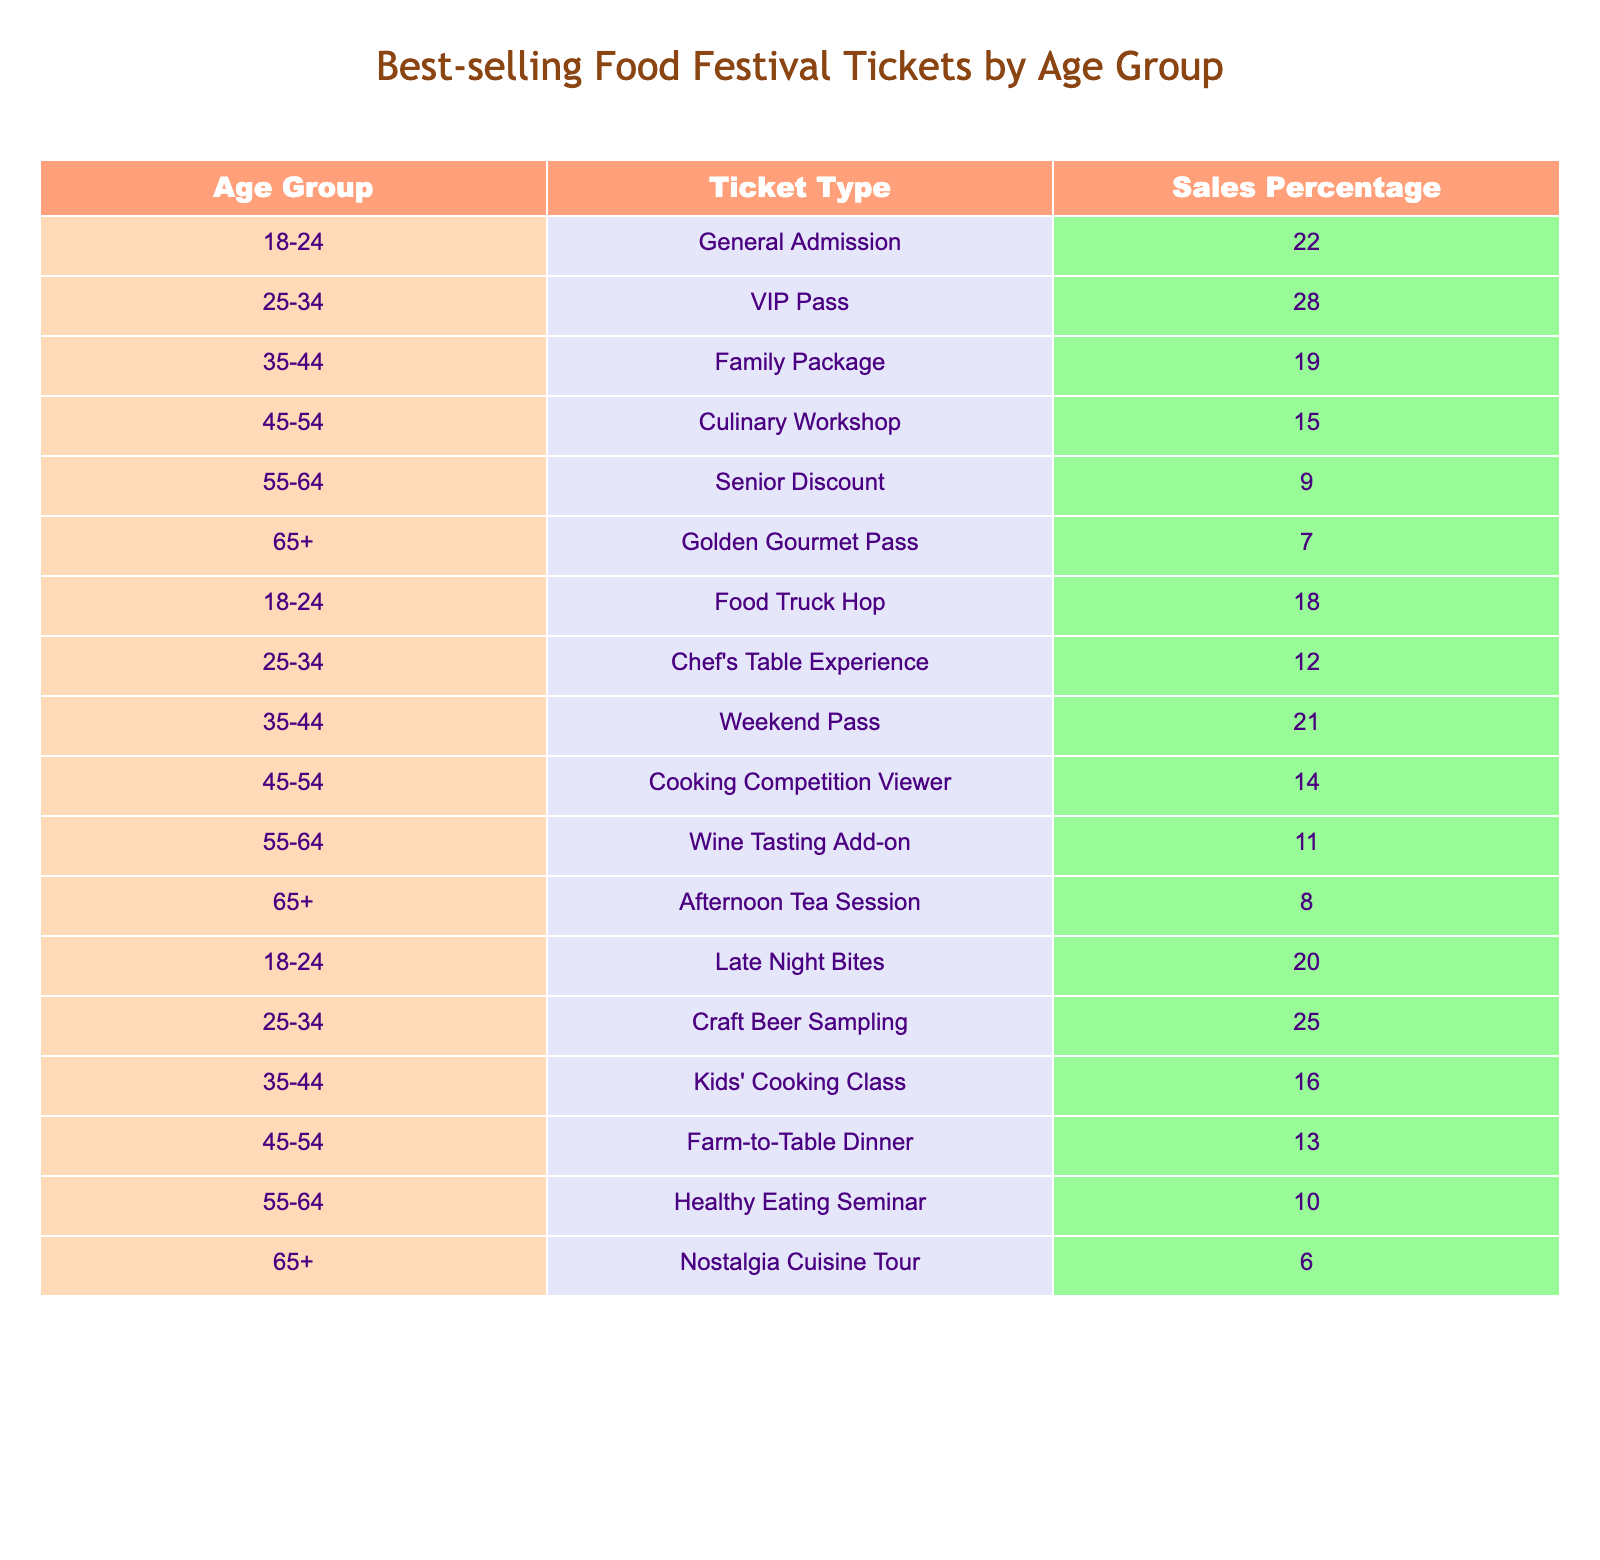What age group has the highest sales percentage for the VIP Pass? The table shows that the 25-34 age group has a sales percentage of 28% for the VIP Pass, which is the highest among the listed groups for this ticket type.
Answer: 25-34 What is the total sales percentage for the 45-54 age group across all ticket types? The sales percentages for the 45-54 age group are 15% (Culinary Workshop), 14% (Cooking Competition Viewer), and 13% (Farm-to-Table Dinner). Adding these together: 15 + 14 + 13 = 42%.
Answer: 42% Is there a ticket type that has the same sales percentage across multiple age groups? Yes, the tickets for the Weekend Pass (21%) and Culinary Workshop (15%) represent the same sales percentages for different age groups.
Answer: Yes What is the sales percentage difference between the age group 35-44 for the Family Package and the Weekend Pass? The sales percentage for the Family Package (19%) and Weekend Pass (21%) yields a difference of 21 - 19 = 2%.
Answer: 2% Which ticket type has the lowest sales percentage and which age group does it correspond to? The Nostalgia Cuisine Tour has the lowest sales percentage of 6%, which corresponds to the 65+ age group.
Answer: Nostalgia Cuisine Tour; 65+ What is the average sales percentage for all ticket types in the 18-24 age group? For the 18-24 age group, the sales percentages are 22% (General Admission), 18% (Food Truck Hop), 20% (Late Night Bites). To find the average, sum these values: 22 + 18 + 20 = 60, then divide by 3. Thus, 60 / 3 = 20%.
Answer: 20% Do more people in the 55-64 age group prefer the Healthy Eating Seminar or the Wine Tasting Add-on? The Healthy Eating Seminar has a sales percentage of 10%, while the Wine Tasting Add-on has 11%. Since 11% > 10%, more people prefer the Wine Tasting Add-on.
Answer: Wine Tasting Add-on What is the cumulative sales percentage for the 65+ age group across all ticket types? The sales percentages for the 65+ age group are 7% (Golden Gourmet Pass), 8% (Afternoon Tea Session), and 6% (Nostalgia Cuisine Tour). Adding these gives 7 + 8 + 6 = 21%.
Answer: 21% 